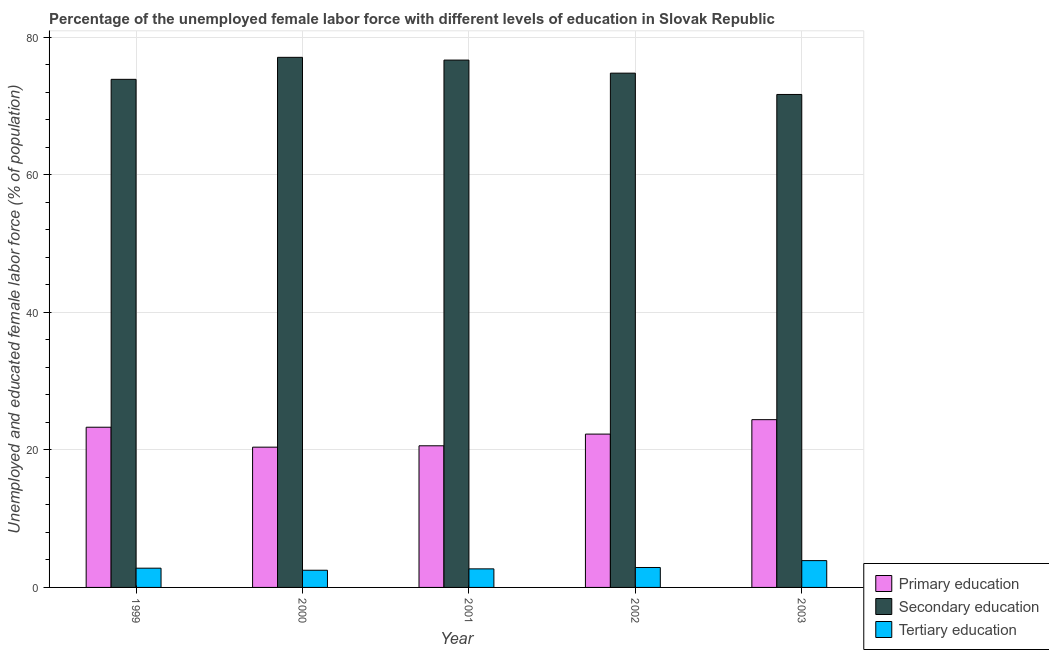How many groups of bars are there?
Offer a terse response. 5. What is the label of the 4th group of bars from the left?
Provide a short and direct response. 2002. In how many cases, is the number of bars for a given year not equal to the number of legend labels?
Give a very brief answer. 0. What is the percentage of female labor force who received tertiary education in 1999?
Keep it short and to the point. 2.8. Across all years, what is the maximum percentage of female labor force who received tertiary education?
Your answer should be very brief. 3.9. Across all years, what is the minimum percentage of female labor force who received tertiary education?
Provide a short and direct response. 2.5. What is the total percentage of female labor force who received tertiary education in the graph?
Give a very brief answer. 14.8. What is the difference between the percentage of female labor force who received primary education in 2000 and that in 2003?
Your answer should be very brief. -4. What is the difference between the percentage of female labor force who received tertiary education in 1999 and the percentage of female labor force who received secondary education in 2002?
Give a very brief answer. -0.1. What is the average percentage of female labor force who received tertiary education per year?
Make the answer very short. 2.96. In how many years, is the percentage of female labor force who received primary education greater than 72 %?
Make the answer very short. 0. What is the ratio of the percentage of female labor force who received tertiary education in 1999 to that in 2001?
Your answer should be very brief. 1.04. Is the difference between the percentage of female labor force who received secondary education in 1999 and 2001 greater than the difference between the percentage of female labor force who received primary education in 1999 and 2001?
Your response must be concise. No. What is the difference between the highest and the lowest percentage of female labor force who received secondary education?
Your answer should be compact. 5.4. What does the 3rd bar from the left in 2000 represents?
Your answer should be very brief. Tertiary education. What does the 2nd bar from the right in 2002 represents?
Your answer should be very brief. Secondary education. How many bars are there?
Offer a terse response. 15. How many years are there in the graph?
Provide a short and direct response. 5. What is the difference between two consecutive major ticks on the Y-axis?
Provide a short and direct response. 20. Are the values on the major ticks of Y-axis written in scientific E-notation?
Keep it short and to the point. No. Does the graph contain any zero values?
Give a very brief answer. No. Where does the legend appear in the graph?
Provide a short and direct response. Bottom right. How many legend labels are there?
Provide a short and direct response. 3. What is the title of the graph?
Your answer should be compact. Percentage of the unemployed female labor force with different levels of education in Slovak Republic. What is the label or title of the X-axis?
Your answer should be compact. Year. What is the label or title of the Y-axis?
Your answer should be compact. Unemployed and educated female labor force (% of population). What is the Unemployed and educated female labor force (% of population) in Primary education in 1999?
Your answer should be very brief. 23.3. What is the Unemployed and educated female labor force (% of population) in Secondary education in 1999?
Your answer should be compact. 73.9. What is the Unemployed and educated female labor force (% of population) of Tertiary education in 1999?
Give a very brief answer. 2.8. What is the Unemployed and educated female labor force (% of population) in Primary education in 2000?
Your answer should be compact. 20.4. What is the Unemployed and educated female labor force (% of population) in Secondary education in 2000?
Provide a succinct answer. 77.1. What is the Unemployed and educated female labor force (% of population) of Tertiary education in 2000?
Provide a succinct answer. 2.5. What is the Unemployed and educated female labor force (% of population) of Primary education in 2001?
Provide a succinct answer. 20.6. What is the Unemployed and educated female labor force (% of population) in Secondary education in 2001?
Give a very brief answer. 76.7. What is the Unemployed and educated female labor force (% of population) of Tertiary education in 2001?
Ensure brevity in your answer.  2.7. What is the Unemployed and educated female labor force (% of population) of Primary education in 2002?
Provide a succinct answer. 22.3. What is the Unemployed and educated female labor force (% of population) of Secondary education in 2002?
Provide a short and direct response. 74.8. What is the Unemployed and educated female labor force (% of population) of Tertiary education in 2002?
Your answer should be compact. 2.9. What is the Unemployed and educated female labor force (% of population) in Primary education in 2003?
Offer a very short reply. 24.4. What is the Unemployed and educated female labor force (% of population) of Secondary education in 2003?
Give a very brief answer. 71.7. What is the Unemployed and educated female labor force (% of population) of Tertiary education in 2003?
Make the answer very short. 3.9. Across all years, what is the maximum Unemployed and educated female labor force (% of population) of Primary education?
Provide a short and direct response. 24.4. Across all years, what is the maximum Unemployed and educated female labor force (% of population) in Secondary education?
Provide a short and direct response. 77.1. Across all years, what is the maximum Unemployed and educated female labor force (% of population) of Tertiary education?
Ensure brevity in your answer.  3.9. Across all years, what is the minimum Unemployed and educated female labor force (% of population) of Primary education?
Make the answer very short. 20.4. Across all years, what is the minimum Unemployed and educated female labor force (% of population) of Secondary education?
Your answer should be very brief. 71.7. What is the total Unemployed and educated female labor force (% of population) of Primary education in the graph?
Offer a terse response. 111. What is the total Unemployed and educated female labor force (% of population) in Secondary education in the graph?
Your answer should be very brief. 374.2. What is the total Unemployed and educated female labor force (% of population) in Tertiary education in the graph?
Keep it short and to the point. 14.8. What is the difference between the Unemployed and educated female labor force (% of population) of Primary education in 1999 and that in 2000?
Offer a terse response. 2.9. What is the difference between the Unemployed and educated female labor force (% of population) in Tertiary education in 1999 and that in 2000?
Provide a succinct answer. 0.3. What is the difference between the Unemployed and educated female labor force (% of population) of Secondary education in 1999 and that in 2001?
Provide a short and direct response. -2.8. What is the difference between the Unemployed and educated female labor force (% of population) of Tertiary education in 1999 and that in 2002?
Your response must be concise. -0.1. What is the difference between the Unemployed and educated female labor force (% of population) in Tertiary education in 1999 and that in 2003?
Offer a terse response. -1.1. What is the difference between the Unemployed and educated female labor force (% of population) of Secondary education in 2000 and that in 2001?
Provide a succinct answer. 0.4. What is the difference between the Unemployed and educated female labor force (% of population) in Tertiary education in 2000 and that in 2001?
Make the answer very short. -0.2. What is the difference between the Unemployed and educated female labor force (% of population) of Primary education in 2000 and that in 2003?
Your answer should be compact. -4. What is the difference between the Unemployed and educated female labor force (% of population) in Tertiary education in 2001 and that in 2002?
Your response must be concise. -0.2. What is the difference between the Unemployed and educated female labor force (% of population) of Primary education in 2001 and that in 2003?
Your answer should be compact. -3.8. What is the difference between the Unemployed and educated female labor force (% of population) in Secondary education in 2001 and that in 2003?
Make the answer very short. 5. What is the difference between the Unemployed and educated female labor force (% of population) in Tertiary education in 2001 and that in 2003?
Offer a terse response. -1.2. What is the difference between the Unemployed and educated female labor force (% of population) in Secondary education in 2002 and that in 2003?
Provide a short and direct response. 3.1. What is the difference between the Unemployed and educated female labor force (% of population) of Primary education in 1999 and the Unemployed and educated female labor force (% of population) of Secondary education in 2000?
Offer a terse response. -53.8. What is the difference between the Unemployed and educated female labor force (% of population) of Primary education in 1999 and the Unemployed and educated female labor force (% of population) of Tertiary education in 2000?
Make the answer very short. 20.8. What is the difference between the Unemployed and educated female labor force (% of population) of Secondary education in 1999 and the Unemployed and educated female labor force (% of population) of Tertiary education in 2000?
Provide a succinct answer. 71.4. What is the difference between the Unemployed and educated female labor force (% of population) in Primary education in 1999 and the Unemployed and educated female labor force (% of population) in Secondary education in 2001?
Give a very brief answer. -53.4. What is the difference between the Unemployed and educated female labor force (% of population) of Primary education in 1999 and the Unemployed and educated female labor force (% of population) of Tertiary education in 2001?
Provide a succinct answer. 20.6. What is the difference between the Unemployed and educated female labor force (% of population) in Secondary education in 1999 and the Unemployed and educated female labor force (% of population) in Tertiary education in 2001?
Give a very brief answer. 71.2. What is the difference between the Unemployed and educated female labor force (% of population) of Primary education in 1999 and the Unemployed and educated female labor force (% of population) of Secondary education in 2002?
Your response must be concise. -51.5. What is the difference between the Unemployed and educated female labor force (% of population) of Primary education in 1999 and the Unemployed and educated female labor force (% of population) of Tertiary education in 2002?
Make the answer very short. 20.4. What is the difference between the Unemployed and educated female labor force (% of population) in Primary education in 1999 and the Unemployed and educated female labor force (% of population) in Secondary education in 2003?
Your response must be concise. -48.4. What is the difference between the Unemployed and educated female labor force (% of population) of Primary education in 1999 and the Unemployed and educated female labor force (% of population) of Tertiary education in 2003?
Give a very brief answer. 19.4. What is the difference between the Unemployed and educated female labor force (% of population) of Secondary education in 1999 and the Unemployed and educated female labor force (% of population) of Tertiary education in 2003?
Your response must be concise. 70. What is the difference between the Unemployed and educated female labor force (% of population) of Primary education in 2000 and the Unemployed and educated female labor force (% of population) of Secondary education in 2001?
Ensure brevity in your answer.  -56.3. What is the difference between the Unemployed and educated female labor force (% of population) in Primary education in 2000 and the Unemployed and educated female labor force (% of population) in Tertiary education in 2001?
Your response must be concise. 17.7. What is the difference between the Unemployed and educated female labor force (% of population) of Secondary education in 2000 and the Unemployed and educated female labor force (% of population) of Tertiary education in 2001?
Keep it short and to the point. 74.4. What is the difference between the Unemployed and educated female labor force (% of population) in Primary education in 2000 and the Unemployed and educated female labor force (% of population) in Secondary education in 2002?
Offer a terse response. -54.4. What is the difference between the Unemployed and educated female labor force (% of population) in Primary education in 2000 and the Unemployed and educated female labor force (% of population) in Tertiary education in 2002?
Make the answer very short. 17.5. What is the difference between the Unemployed and educated female labor force (% of population) of Secondary education in 2000 and the Unemployed and educated female labor force (% of population) of Tertiary education in 2002?
Your response must be concise. 74.2. What is the difference between the Unemployed and educated female labor force (% of population) in Primary education in 2000 and the Unemployed and educated female labor force (% of population) in Secondary education in 2003?
Offer a very short reply. -51.3. What is the difference between the Unemployed and educated female labor force (% of population) in Secondary education in 2000 and the Unemployed and educated female labor force (% of population) in Tertiary education in 2003?
Offer a terse response. 73.2. What is the difference between the Unemployed and educated female labor force (% of population) of Primary education in 2001 and the Unemployed and educated female labor force (% of population) of Secondary education in 2002?
Provide a succinct answer. -54.2. What is the difference between the Unemployed and educated female labor force (% of population) in Secondary education in 2001 and the Unemployed and educated female labor force (% of population) in Tertiary education in 2002?
Keep it short and to the point. 73.8. What is the difference between the Unemployed and educated female labor force (% of population) of Primary education in 2001 and the Unemployed and educated female labor force (% of population) of Secondary education in 2003?
Give a very brief answer. -51.1. What is the difference between the Unemployed and educated female labor force (% of population) in Secondary education in 2001 and the Unemployed and educated female labor force (% of population) in Tertiary education in 2003?
Provide a succinct answer. 72.8. What is the difference between the Unemployed and educated female labor force (% of population) of Primary education in 2002 and the Unemployed and educated female labor force (% of population) of Secondary education in 2003?
Keep it short and to the point. -49.4. What is the difference between the Unemployed and educated female labor force (% of population) of Secondary education in 2002 and the Unemployed and educated female labor force (% of population) of Tertiary education in 2003?
Offer a terse response. 70.9. What is the average Unemployed and educated female labor force (% of population) in Secondary education per year?
Provide a short and direct response. 74.84. What is the average Unemployed and educated female labor force (% of population) of Tertiary education per year?
Offer a terse response. 2.96. In the year 1999, what is the difference between the Unemployed and educated female labor force (% of population) of Primary education and Unemployed and educated female labor force (% of population) of Secondary education?
Keep it short and to the point. -50.6. In the year 1999, what is the difference between the Unemployed and educated female labor force (% of population) of Secondary education and Unemployed and educated female labor force (% of population) of Tertiary education?
Provide a succinct answer. 71.1. In the year 2000, what is the difference between the Unemployed and educated female labor force (% of population) of Primary education and Unemployed and educated female labor force (% of population) of Secondary education?
Give a very brief answer. -56.7. In the year 2000, what is the difference between the Unemployed and educated female labor force (% of population) of Secondary education and Unemployed and educated female labor force (% of population) of Tertiary education?
Give a very brief answer. 74.6. In the year 2001, what is the difference between the Unemployed and educated female labor force (% of population) in Primary education and Unemployed and educated female labor force (% of population) in Secondary education?
Offer a very short reply. -56.1. In the year 2002, what is the difference between the Unemployed and educated female labor force (% of population) in Primary education and Unemployed and educated female labor force (% of population) in Secondary education?
Offer a terse response. -52.5. In the year 2002, what is the difference between the Unemployed and educated female labor force (% of population) of Secondary education and Unemployed and educated female labor force (% of population) of Tertiary education?
Provide a succinct answer. 71.9. In the year 2003, what is the difference between the Unemployed and educated female labor force (% of population) of Primary education and Unemployed and educated female labor force (% of population) of Secondary education?
Give a very brief answer. -47.3. In the year 2003, what is the difference between the Unemployed and educated female labor force (% of population) in Secondary education and Unemployed and educated female labor force (% of population) in Tertiary education?
Your answer should be very brief. 67.8. What is the ratio of the Unemployed and educated female labor force (% of population) in Primary education in 1999 to that in 2000?
Your answer should be compact. 1.14. What is the ratio of the Unemployed and educated female labor force (% of population) in Secondary education in 1999 to that in 2000?
Provide a succinct answer. 0.96. What is the ratio of the Unemployed and educated female labor force (% of population) of Tertiary education in 1999 to that in 2000?
Give a very brief answer. 1.12. What is the ratio of the Unemployed and educated female labor force (% of population) in Primary education in 1999 to that in 2001?
Offer a terse response. 1.13. What is the ratio of the Unemployed and educated female labor force (% of population) of Secondary education in 1999 to that in 2001?
Provide a succinct answer. 0.96. What is the ratio of the Unemployed and educated female labor force (% of population) in Tertiary education in 1999 to that in 2001?
Keep it short and to the point. 1.04. What is the ratio of the Unemployed and educated female labor force (% of population) in Primary education in 1999 to that in 2002?
Ensure brevity in your answer.  1.04. What is the ratio of the Unemployed and educated female labor force (% of population) of Tertiary education in 1999 to that in 2002?
Ensure brevity in your answer.  0.97. What is the ratio of the Unemployed and educated female labor force (% of population) in Primary education in 1999 to that in 2003?
Provide a succinct answer. 0.95. What is the ratio of the Unemployed and educated female labor force (% of population) of Secondary education in 1999 to that in 2003?
Your answer should be very brief. 1.03. What is the ratio of the Unemployed and educated female labor force (% of population) of Tertiary education in 1999 to that in 2003?
Your response must be concise. 0.72. What is the ratio of the Unemployed and educated female labor force (% of population) of Primary education in 2000 to that in 2001?
Your answer should be compact. 0.99. What is the ratio of the Unemployed and educated female labor force (% of population) of Secondary education in 2000 to that in 2001?
Your answer should be very brief. 1.01. What is the ratio of the Unemployed and educated female labor force (% of population) of Tertiary education in 2000 to that in 2001?
Your answer should be compact. 0.93. What is the ratio of the Unemployed and educated female labor force (% of population) of Primary education in 2000 to that in 2002?
Your answer should be compact. 0.91. What is the ratio of the Unemployed and educated female labor force (% of population) in Secondary education in 2000 to that in 2002?
Your response must be concise. 1.03. What is the ratio of the Unemployed and educated female labor force (% of population) of Tertiary education in 2000 to that in 2002?
Give a very brief answer. 0.86. What is the ratio of the Unemployed and educated female labor force (% of population) in Primary education in 2000 to that in 2003?
Provide a succinct answer. 0.84. What is the ratio of the Unemployed and educated female labor force (% of population) in Secondary education in 2000 to that in 2003?
Your response must be concise. 1.08. What is the ratio of the Unemployed and educated female labor force (% of population) of Tertiary education in 2000 to that in 2003?
Offer a very short reply. 0.64. What is the ratio of the Unemployed and educated female labor force (% of population) of Primary education in 2001 to that in 2002?
Your answer should be very brief. 0.92. What is the ratio of the Unemployed and educated female labor force (% of population) in Secondary education in 2001 to that in 2002?
Your response must be concise. 1.03. What is the ratio of the Unemployed and educated female labor force (% of population) of Primary education in 2001 to that in 2003?
Your answer should be compact. 0.84. What is the ratio of the Unemployed and educated female labor force (% of population) in Secondary education in 2001 to that in 2003?
Your answer should be compact. 1.07. What is the ratio of the Unemployed and educated female labor force (% of population) in Tertiary education in 2001 to that in 2003?
Give a very brief answer. 0.69. What is the ratio of the Unemployed and educated female labor force (% of population) in Primary education in 2002 to that in 2003?
Offer a very short reply. 0.91. What is the ratio of the Unemployed and educated female labor force (% of population) of Secondary education in 2002 to that in 2003?
Your response must be concise. 1.04. What is the ratio of the Unemployed and educated female labor force (% of population) of Tertiary education in 2002 to that in 2003?
Keep it short and to the point. 0.74. What is the difference between the highest and the lowest Unemployed and educated female labor force (% of population) of Secondary education?
Ensure brevity in your answer.  5.4. What is the difference between the highest and the lowest Unemployed and educated female labor force (% of population) of Tertiary education?
Offer a very short reply. 1.4. 